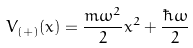Convert formula to latex. <formula><loc_0><loc_0><loc_500><loc_500>V _ { ( + ) } ( x ) = \frac { m \omega ^ { 2 } } { 2 } x ^ { 2 } + \frac { \hbar { \omega } } { 2 }</formula> 